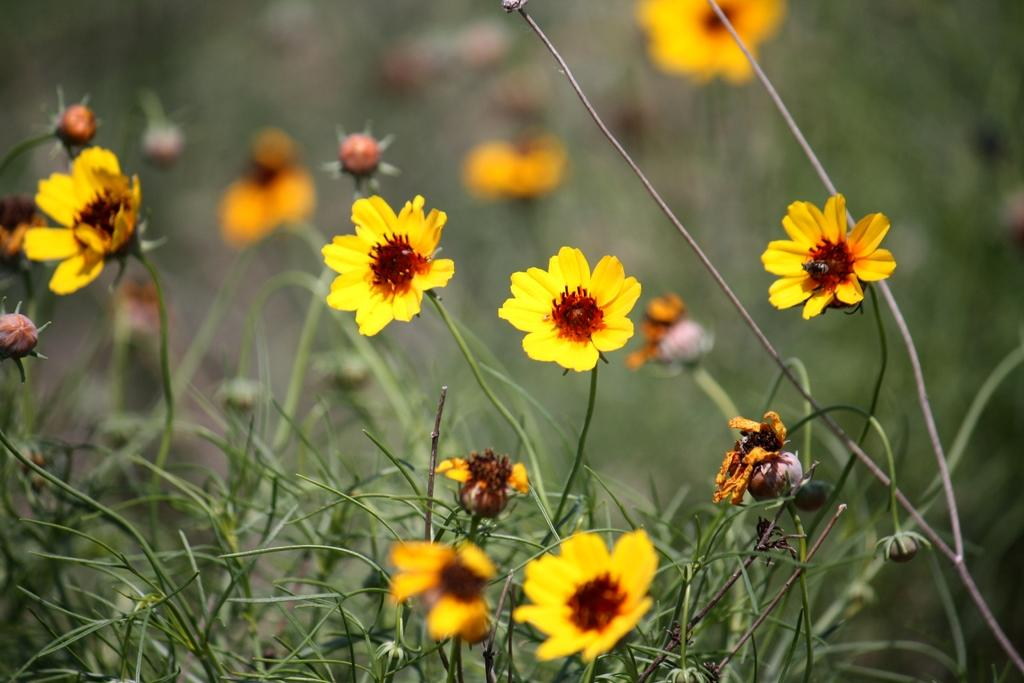What type of plants can be seen in the image? There are plants with flowers in the image. What can be found in the middle of the flowers? Pollen grains are present in the middle of the flowers. How many cars can be seen driving through the flowers in the image? There are no cars present in the image; it features flowers on plants with pollen grains. 